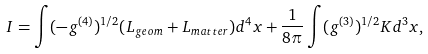<formula> <loc_0><loc_0><loc_500><loc_500>I = \int ( - g ^ { ( 4 ) } ) ^ { 1 / 2 } ( L _ { g e o m } + L _ { m a t t e r } ) d ^ { 4 } x + \frac { 1 } { 8 \pi } \int ( g ^ { ( 3 ) } ) ^ { 1 / 2 } K d ^ { 3 } x ,</formula> 